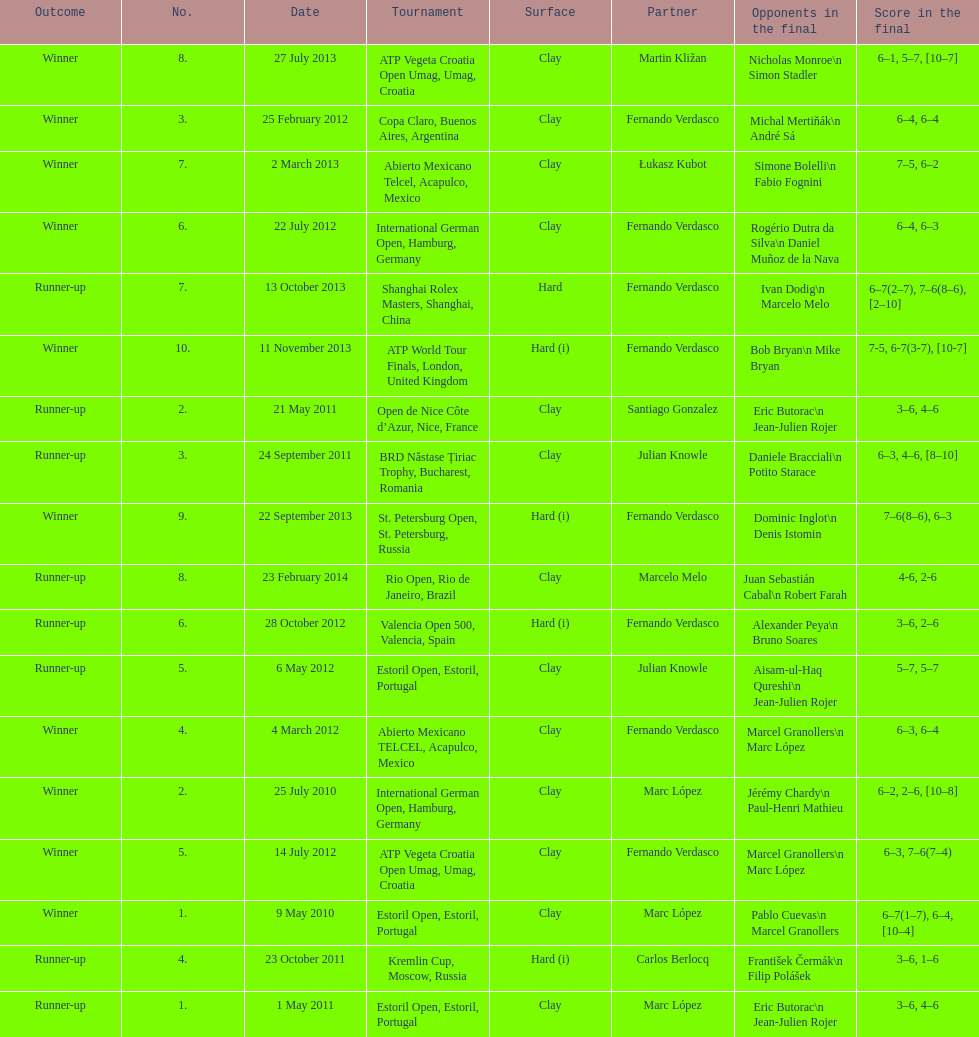What tournament was before the estoril open? Abierto Mexicano TELCEL, Acapulco, Mexico. 